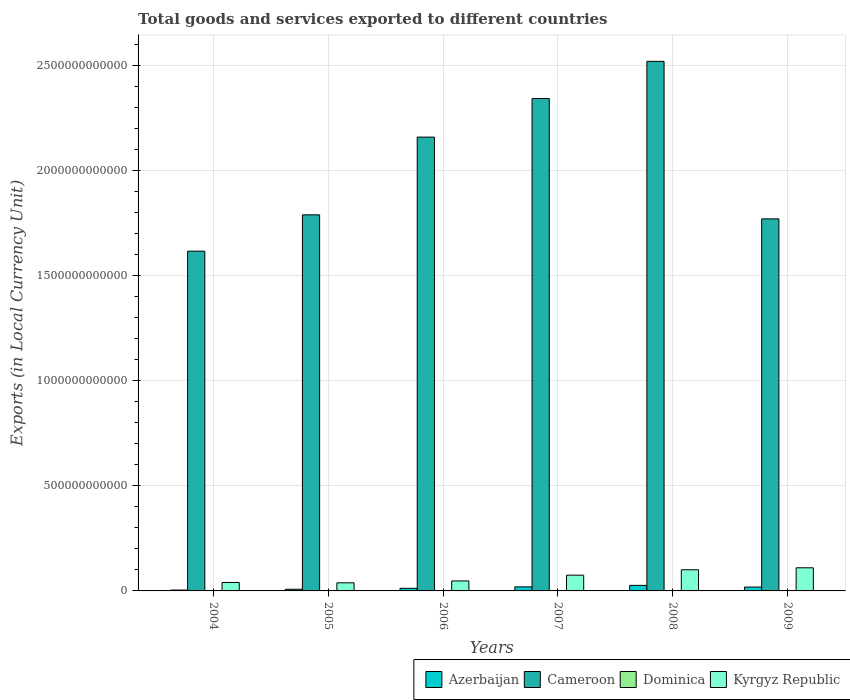How many different coloured bars are there?
Keep it short and to the point. 4. How many groups of bars are there?
Keep it short and to the point. 6. What is the Amount of goods and services exports in Azerbaijan in 2009?
Offer a very short reply. 1.84e+1. Across all years, what is the maximum Amount of goods and services exports in Kyrgyz Republic?
Give a very brief answer. 1.10e+11. Across all years, what is the minimum Amount of goods and services exports in Cameroon?
Offer a very short reply. 1.62e+12. What is the total Amount of goods and services exports in Azerbaijan in the graph?
Give a very brief answer. 8.86e+1. What is the difference between the Amount of goods and services exports in Dominica in 2007 and that in 2008?
Keep it short and to the point. -2.40e+07. What is the difference between the Amount of goods and services exports in Azerbaijan in 2007 and the Amount of goods and services exports in Dominica in 2006?
Make the answer very short. 1.89e+1. What is the average Amount of goods and services exports in Azerbaijan per year?
Ensure brevity in your answer.  1.48e+1. In the year 2004, what is the difference between the Amount of goods and services exports in Dominica and Amount of goods and services exports in Kyrgyz Republic?
Your answer should be compact. -3.98e+1. What is the ratio of the Amount of goods and services exports in Cameroon in 2005 to that in 2007?
Provide a short and direct response. 0.76. Is the Amount of goods and services exports in Cameroon in 2006 less than that in 2007?
Keep it short and to the point. Yes. What is the difference between the highest and the second highest Amount of goods and services exports in Azerbaijan?
Your answer should be very brief. 7.08e+09. What is the difference between the highest and the lowest Amount of goods and services exports in Dominica?
Ensure brevity in your answer.  7.40e+07. In how many years, is the Amount of goods and services exports in Azerbaijan greater than the average Amount of goods and services exports in Azerbaijan taken over all years?
Offer a very short reply. 3. What does the 3rd bar from the left in 2005 represents?
Keep it short and to the point. Dominica. What does the 3rd bar from the right in 2006 represents?
Provide a short and direct response. Cameroon. Are all the bars in the graph horizontal?
Offer a terse response. No. How many years are there in the graph?
Make the answer very short. 6. What is the difference between two consecutive major ticks on the Y-axis?
Give a very brief answer. 5.00e+11. Are the values on the major ticks of Y-axis written in scientific E-notation?
Offer a very short reply. No. Does the graph contain grids?
Provide a succinct answer. Yes. Where does the legend appear in the graph?
Offer a very short reply. Bottom right. How are the legend labels stacked?
Your response must be concise. Horizontal. What is the title of the graph?
Provide a succinct answer. Total goods and services exported to different countries. What is the label or title of the Y-axis?
Ensure brevity in your answer.  Exports (in Local Currency Unit). What is the Exports (in Local Currency Unit) in Azerbaijan in 2004?
Provide a short and direct response. 4.16e+09. What is the Exports (in Local Currency Unit) of Cameroon in 2004?
Make the answer very short. 1.62e+12. What is the Exports (in Local Currency Unit) in Dominica in 2004?
Your response must be concise. 3.52e+08. What is the Exports (in Local Currency Unit) in Kyrgyz Republic in 2004?
Provide a succinct answer. 4.02e+1. What is the Exports (in Local Currency Unit) in Azerbaijan in 2005?
Offer a very short reply. 7.88e+09. What is the Exports (in Local Currency Unit) of Cameroon in 2005?
Make the answer very short. 1.79e+12. What is the Exports (in Local Currency Unit) in Dominica in 2005?
Make the answer very short. 3.49e+08. What is the Exports (in Local Currency Unit) in Kyrgyz Republic in 2005?
Provide a succinct answer. 3.86e+1. What is the Exports (in Local Currency Unit) in Azerbaijan in 2006?
Your response must be concise. 1.25e+1. What is the Exports (in Local Currency Unit) of Cameroon in 2006?
Provide a short and direct response. 2.16e+12. What is the Exports (in Local Currency Unit) of Dominica in 2006?
Give a very brief answer. 3.90e+08. What is the Exports (in Local Currency Unit) of Kyrgyz Republic in 2006?
Give a very brief answer. 4.75e+1. What is the Exports (in Local Currency Unit) in Azerbaijan in 2007?
Your answer should be compact. 1.93e+1. What is the Exports (in Local Currency Unit) in Cameroon in 2007?
Provide a short and direct response. 2.34e+12. What is the Exports (in Local Currency Unit) in Dominica in 2007?
Give a very brief answer. 3.99e+08. What is the Exports (in Local Currency Unit) of Kyrgyz Republic in 2007?
Offer a terse response. 7.51e+1. What is the Exports (in Local Currency Unit) of Azerbaijan in 2008?
Provide a short and direct response. 2.64e+1. What is the Exports (in Local Currency Unit) in Cameroon in 2008?
Your answer should be very brief. 2.52e+12. What is the Exports (in Local Currency Unit) of Dominica in 2008?
Give a very brief answer. 4.23e+08. What is the Exports (in Local Currency Unit) in Kyrgyz Republic in 2008?
Give a very brief answer. 1.01e+11. What is the Exports (in Local Currency Unit) in Azerbaijan in 2009?
Your answer should be compact. 1.84e+1. What is the Exports (in Local Currency Unit) of Cameroon in 2009?
Your answer should be very brief. 1.77e+12. What is the Exports (in Local Currency Unit) in Dominica in 2009?
Provide a short and direct response. 3.99e+08. What is the Exports (in Local Currency Unit) of Kyrgyz Republic in 2009?
Give a very brief answer. 1.10e+11. Across all years, what is the maximum Exports (in Local Currency Unit) of Azerbaijan?
Offer a terse response. 2.64e+1. Across all years, what is the maximum Exports (in Local Currency Unit) of Cameroon?
Give a very brief answer. 2.52e+12. Across all years, what is the maximum Exports (in Local Currency Unit) of Dominica?
Offer a terse response. 4.23e+08. Across all years, what is the maximum Exports (in Local Currency Unit) of Kyrgyz Republic?
Keep it short and to the point. 1.10e+11. Across all years, what is the minimum Exports (in Local Currency Unit) in Azerbaijan?
Your answer should be compact. 4.16e+09. Across all years, what is the minimum Exports (in Local Currency Unit) of Cameroon?
Ensure brevity in your answer.  1.62e+12. Across all years, what is the minimum Exports (in Local Currency Unit) of Dominica?
Ensure brevity in your answer.  3.49e+08. Across all years, what is the minimum Exports (in Local Currency Unit) in Kyrgyz Republic?
Keep it short and to the point. 3.86e+1. What is the total Exports (in Local Currency Unit) of Azerbaijan in the graph?
Make the answer very short. 8.86e+1. What is the total Exports (in Local Currency Unit) of Cameroon in the graph?
Keep it short and to the point. 1.22e+13. What is the total Exports (in Local Currency Unit) of Dominica in the graph?
Provide a short and direct response. 2.31e+09. What is the total Exports (in Local Currency Unit) of Kyrgyz Republic in the graph?
Provide a short and direct response. 4.12e+11. What is the difference between the Exports (in Local Currency Unit) of Azerbaijan in 2004 and that in 2005?
Give a very brief answer. -3.72e+09. What is the difference between the Exports (in Local Currency Unit) in Cameroon in 2004 and that in 2005?
Provide a short and direct response. -1.73e+11. What is the difference between the Exports (in Local Currency Unit) of Dominica in 2004 and that in 2005?
Offer a terse response. 3.29e+06. What is the difference between the Exports (in Local Currency Unit) in Kyrgyz Republic in 2004 and that in 2005?
Make the answer very short. 1.50e+09. What is the difference between the Exports (in Local Currency Unit) of Azerbaijan in 2004 and that in 2006?
Offer a very short reply. -8.31e+09. What is the difference between the Exports (in Local Currency Unit) in Cameroon in 2004 and that in 2006?
Your answer should be very brief. -5.43e+11. What is the difference between the Exports (in Local Currency Unit) in Dominica in 2004 and that in 2006?
Keep it short and to the point. -3.77e+07. What is the difference between the Exports (in Local Currency Unit) in Kyrgyz Republic in 2004 and that in 2006?
Provide a succinct answer. -7.33e+09. What is the difference between the Exports (in Local Currency Unit) of Azerbaijan in 2004 and that in 2007?
Make the answer very short. -1.52e+1. What is the difference between the Exports (in Local Currency Unit) in Cameroon in 2004 and that in 2007?
Offer a terse response. -7.26e+11. What is the difference between the Exports (in Local Currency Unit) of Dominica in 2004 and that in 2007?
Provide a succinct answer. -4.67e+07. What is the difference between the Exports (in Local Currency Unit) in Kyrgyz Republic in 2004 and that in 2007?
Keep it short and to the point. -3.49e+1. What is the difference between the Exports (in Local Currency Unit) of Azerbaijan in 2004 and that in 2008?
Your answer should be very brief. -2.22e+1. What is the difference between the Exports (in Local Currency Unit) in Cameroon in 2004 and that in 2008?
Ensure brevity in your answer.  -9.03e+11. What is the difference between the Exports (in Local Currency Unit) of Dominica in 2004 and that in 2008?
Provide a succinct answer. -7.07e+07. What is the difference between the Exports (in Local Currency Unit) of Kyrgyz Republic in 2004 and that in 2008?
Make the answer very short. -6.05e+1. What is the difference between the Exports (in Local Currency Unit) of Azerbaijan in 2004 and that in 2009?
Your answer should be very brief. -1.42e+1. What is the difference between the Exports (in Local Currency Unit) in Cameroon in 2004 and that in 2009?
Ensure brevity in your answer.  -1.54e+11. What is the difference between the Exports (in Local Currency Unit) of Dominica in 2004 and that in 2009?
Your response must be concise. -4.67e+07. What is the difference between the Exports (in Local Currency Unit) in Kyrgyz Republic in 2004 and that in 2009?
Offer a terse response. -6.99e+1. What is the difference between the Exports (in Local Currency Unit) in Azerbaijan in 2005 and that in 2006?
Your answer should be compact. -4.59e+09. What is the difference between the Exports (in Local Currency Unit) in Cameroon in 2005 and that in 2006?
Provide a short and direct response. -3.70e+11. What is the difference between the Exports (in Local Currency Unit) in Dominica in 2005 and that in 2006?
Provide a short and direct response. -4.10e+07. What is the difference between the Exports (in Local Currency Unit) of Kyrgyz Republic in 2005 and that in 2006?
Offer a terse response. -8.83e+09. What is the difference between the Exports (in Local Currency Unit) of Azerbaijan in 2005 and that in 2007?
Your answer should be compact. -1.14e+1. What is the difference between the Exports (in Local Currency Unit) in Cameroon in 2005 and that in 2007?
Provide a short and direct response. -5.54e+11. What is the difference between the Exports (in Local Currency Unit) of Dominica in 2005 and that in 2007?
Provide a succinct answer. -5.00e+07. What is the difference between the Exports (in Local Currency Unit) of Kyrgyz Republic in 2005 and that in 2007?
Your answer should be compact. -3.64e+1. What is the difference between the Exports (in Local Currency Unit) of Azerbaijan in 2005 and that in 2008?
Offer a very short reply. -1.85e+1. What is the difference between the Exports (in Local Currency Unit) in Cameroon in 2005 and that in 2008?
Offer a terse response. -7.30e+11. What is the difference between the Exports (in Local Currency Unit) in Dominica in 2005 and that in 2008?
Offer a terse response. -7.40e+07. What is the difference between the Exports (in Local Currency Unit) in Kyrgyz Republic in 2005 and that in 2008?
Make the answer very short. -6.20e+1. What is the difference between the Exports (in Local Currency Unit) in Azerbaijan in 2005 and that in 2009?
Offer a very short reply. -1.05e+1. What is the difference between the Exports (in Local Currency Unit) of Cameroon in 2005 and that in 2009?
Your answer should be very brief. 1.92e+1. What is the difference between the Exports (in Local Currency Unit) of Dominica in 2005 and that in 2009?
Give a very brief answer. -5.00e+07. What is the difference between the Exports (in Local Currency Unit) in Kyrgyz Republic in 2005 and that in 2009?
Ensure brevity in your answer.  -7.14e+1. What is the difference between the Exports (in Local Currency Unit) in Azerbaijan in 2006 and that in 2007?
Ensure brevity in your answer.  -6.85e+09. What is the difference between the Exports (in Local Currency Unit) of Cameroon in 2006 and that in 2007?
Provide a short and direct response. -1.84e+11. What is the difference between the Exports (in Local Currency Unit) in Dominica in 2006 and that in 2007?
Your response must be concise. -9.00e+06. What is the difference between the Exports (in Local Currency Unit) of Kyrgyz Republic in 2006 and that in 2007?
Offer a very short reply. -2.76e+1. What is the difference between the Exports (in Local Currency Unit) in Azerbaijan in 2006 and that in 2008?
Offer a very short reply. -1.39e+1. What is the difference between the Exports (in Local Currency Unit) in Cameroon in 2006 and that in 2008?
Give a very brief answer. -3.61e+11. What is the difference between the Exports (in Local Currency Unit) in Dominica in 2006 and that in 2008?
Ensure brevity in your answer.  -3.30e+07. What is the difference between the Exports (in Local Currency Unit) in Kyrgyz Republic in 2006 and that in 2008?
Your response must be concise. -5.32e+1. What is the difference between the Exports (in Local Currency Unit) of Azerbaijan in 2006 and that in 2009?
Your answer should be compact. -5.92e+09. What is the difference between the Exports (in Local Currency Unit) of Cameroon in 2006 and that in 2009?
Keep it short and to the point. 3.89e+11. What is the difference between the Exports (in Local Currency Unit) in Dominica in 2006 and that in 2009?
Offer a terse response. -9.00e+06. What is the difference between the Exports (in Local Currency Unit) in Kyrgyz Republic in 2006 and that in 2009?
Provide a succinct answer. -6.26e+1. What is the difference between the Exports (in Local Currency Unit) in Azerbaijan in 2007 and that in 2008?
Offer a very short reply. -7.08e+09. What is the difference between the Exports (in Local Currency Unit) of Cameroon in 2007 and that in 2008?
Provide a short and direct response. -1.77e+11. What is the difference between the Exports (in Local Currency Unit) of Dominica in 2007 and that in 2008?
Your answer should be very brief. -2.40e+07. What is the difference between the Exports (in Local Currency Unit) of Kyrgyz Republic in 2007 and that in 2008?
Your response must be concise. -2.56e+1. What is the difference between the Exports (in Local Currency Unit) of Azerbaijan in 2007 and that in 2009?
Give a very brief answer. 9.39e+08. What is the difference between the Exports (in Local Currency Unit) in Cameroon in 2007 and that in 2009?
Keep it short and to the point. 5.73e+11. What is the difference between the Exports (in Local Currency Unit) in Kyrgyz Republic in 2007 and that in 2009?
Keep it short and to the point. -3.50e+1. What is the difference between the Exports (in Local Currency Unit) of Azerbaijan in 2008 and that in 2009?
Provide a short and direct response. 8.02e+09. What is the difference between the Exports (in Local Currency Unit) in Cameroon in 2008 and that in 2009?
Offer a terse response. 7.50e+11. What is the difference between the Exports (in Local Currency Unit) in Dominica in 2008 and that in 2009?
Offer a terse response. 2.40e+07. What is the difference between the Exports (in Local Currency Unit) of Kyrgyz Republic in 2008 and that in 2009?
Ensure brevity in your answer.  -9.40e+09. What is the difference between the Exports (in Local Currency Unit) in Azerbaijan in 2004 and the Exports (in Local Currency Unit) in Cameroon in 2005?
Keep it short and to the point. -1.79e+12. What is the difference between the Exports (in Local Currency Unit) in Azerbaijan in 2004 and the Exports (in Local Currency Unit) in Dominica in 2005?
Your response must be concise. 3.81e+09. What is the difference between the Exports (in Local Currency Unit) in Azerbaijan in 2004 and the Exports (in Local Currency Unit) in Kyrgyz Republic in 2005?
Offer a terse response. -3.45e+1. What is the difference between the Exports (in Local Currency Unit) in Cameroon in 2004 and the Exports (in Local Currency Unit) in Dominica in 2005?
Your response must be concise. 1.62e+12. What is the difference between the Exports (in Local Currency Unit) of Cameroon in 2004 and the Exports (in Local Currency Unit) of Kyrgyz Republic in 2005?
Ensure brevity in your answer.  1.58e+12. What is the difference between the Exports (in Local Currency Unit) in Dominica in 2004 and the Exports (in Local Currency Unit) in Kyrgyz Republic in 2005?
Your answer should be compact. -3.83e+1. What is the difference between the Exports (in Local Currency Unit) in Azerbaijan in 2004 and the Exports (in Local Currency Unit) in Cameroon in 2006?
Offer a terse response. -2.16e+12. What is the difference between the Exports (in Local Currency Unit) in Azerbaijan in 2004 and the Exports (in Local Currency Unit) in Dominica in 2006?
Keep it short and to the point. 3.77e+09. What is the difference between the Exports (in Local Currency Unit) in Azerbaijan in 2004 and the Exports (in Local Currency Unit) in Kyrgyz Republic in 2006?
Ensure brevity in your answer.  -4.33e+1. What is the difference between the Exports (in Local Currency Unit) of Cameroon in 2004 and the Exports (in Local Currency Unit) of Dominica in 2006?
Offer a terse response. 1.62e+12. What is the difference between the Exports (in Local Currency Unit) of Cameroon in 2004 and the Exports (in Local Currency Unit) of Kyrgyz Republic in 2006?
Offer a very short reply. 1.57e+12. What is the difference between the Exports (in Local Currency Unit) of Dominica in 2004 and the Exports (in Local Currency Unit) of Kyrgyz Republic in 2006?
Ensure brevity in your answer.  -4.71e+1. What is the difference between the Exports (in Local Currency Unit) of Azerbaijan in 2004 and the Exports (in Local Currency Unit) of Cameroon in 2007?
Make the answer very short. -2.34e+12. What is the difference between the Exports (in Local Currency Unit) of Azerbaijan in 2004 and the Exports (in Local Currency Unit) of Dominica in 2007?
Your answer should be compact. 3.76e+09. What is the difference between the Exports (in Local Currency Unit) of Azerbaijan in 2004 and the Exports (in Local Currency Unit) of Kyrgyz Republic in 2007?
Ensure brevity in your answer.  -7.09e+1. What is the difference between the Exports (in Local Currency Unit) in Cameroon in 2004 and the Exports (in Local Currency Unit) in Dominica in 2007?
Your response must be concise. 1.62e+12. What is the difference between the Exports (in Local Currency Unit) in Cameroon in 2004 and the Exports (in Local Currency Unit) in Kyrgyz Republic in 2007?
Keep it short and to the point. 1.54e+12. What is the difference between the Exports (in Local Currency Unit) in Dominica in 2004 and the Exports (in Local Currency Unit) in Kyrgyz Republic in 2007?
Offer a very short reply. -7.47e+1. What is the difference between the Exports (in Local Currency Unit) of Azerbaijan in 2004 and the Exports (in Local Currency Unit) of Cameroon in 2008?
Provide a succinct answer. -2.52e+12. What is the difference between the Exports (in Local Currency Unit) of Azerbaijan in 2004 and the Exports (in Local Currency Unit) of Dominica in 2008?
Offer a terse response. 3.74e+09. What is the difference between the Exports (in Local Currency Unit) in Azerbaijan in 2004 and the Exports (in Local Currency Unit) in Kyrgyz Republic in 2008?
Your response must be concise. -9.65e+1. What is the difference between the Exports (in Local Currency Unit) of Cameroon in 2004 and the Exports (in Local Currency Unit) of Dominica in 2008?
Make the answer very short. 1.62e+12. What is the difference between the Exports (in Local Currency Unit) in Cameroon in 2004 and the Exports (in Local Currency Unit) in Kyrgyz Republic in 2008?
Offer a very short reply. 1.52e+12. What is the difference between the Exports (in Local Currency Unit) of Dominica in 2004 and the Exports (in Local Currency Unit) of Kyrgyz Republic in 2008?
Offer a very short reply. -1.00e+11. What is the difference between the Exports (in Local Currency Unit) in Azerbaijan in 2004 and the Exports (in Local Currency Unit) in Cameroon in 2009?
Give a very brief answer. -1.77e+12. What is the difference between the Exports (in Local Currency Unit) in Azerbaijan in 2004 and the Exports (in Local Currency Unit) in Dominica in 2009?
Keep it short and to the point. 3.76e+09. What is the difference between the Exports (in Local Currency Unit) in Azerbaijan in 2004 and the Exports (in Local Currency Unit) in Kyrgyz Republic in 2009?
Provide a short and direct response. -1.06e+11. What is the difference between the Exports (in Local Currency Unit) of Cameroon in 2004 and the Exports (in Local Currency Unit) of Dominica in 2009?
Your response must be concise. 1.62e+12. What is the difference between the Exports (in Local Currency Unit) of Cameroon in 2004 and the Exports (in Local Currency Unit) of Kyrgyz Republic in 2009?
Your answer should be compact. 1.51e+12. What is the difference between the Exports (in Local Currency Unit) of Dominica in 2004 and the Exports (in Local Currency Unit) of Kyrgyz Republic in 2009?
Your response must be concise. -1.10e+11. What is the difference between the Exports (in Local Currency Unit) in Azerbaijan in 2005 and the Exports (in Local Currency Unit) in Cameroon in 2006?
Offer a very short reply. -2.15e+12. What is the difference between the Exports (in Local Currency Unit) of Azerbaijan in 2005 and the Exports (in Local Currency Unit) of Dominica in 2006?
Ensure brevity in your answer.  7.49e+09. What is the difference between the Exports (in Local Currency Unit) of Azerbaijan in 2005 and the Exports (in Local Currency Unit) of Kyrgyz Republic in 2006?
Your answer should be very brief. -3.96e+1. What is the difference between the Exports (in Local Currency Unit) of Cameroon in 2005 and the Exports (in Local Currency Unit) of Dominica in 2006?
Your answer should be compact. 1.79e+12. What is the difference between the Exports (in Local Currency Unit) in Cameroon in 2005 and the Exports (in Local Currency Unit) in Kyrgyz Republic in 2006?
Provide a succinct answer. 1.74e+12. What is the difference between the Exports (in Local Currency Unit) in Dominica in 2005 and the Exports (in Local Currency Unit) in Kyrgyz Republic in 2006?
Your answer should be very brief. -4.71e+1. What is the difference between the Exports (in Local Currency Unit) of Azerbaijan in 2005 and the Exports (in Local Currency Unit) of Cameroon in 2007?
Offer a very short reply. -2.34e+12. What is the difference between the Exports (in Local Currency Unit) in Azerbaijan in 2005 and the Exports (in Local Currency Unit) in Dominica in 2007?
Offer a terse response. 7.48e+09. What is the difference between the Exports (in Local Currency Unit) in Azerbaijan in 2005 and the Exports (in Local Currency Unit) in Kyrgyz Republic in 2007?
Your answer should be very brief. -6.72e+1. What is the difference between the Exports (in Local Currency Unit) of Cameroon in 2005 and the Exports (in Local Currency Unit) of Dominica in 2007?
Make the answer very short. 1.79e+12. What is the difference between the Exports (in Local Currency Unit) in Cameroon in 2005 and the Exports (in Local Currency Unit) in Kyrgyz Republic in 2007?
Offer a very short reply. 1.71e+12. What is the difference between the Exports (in Local Currency Unit) of Dominica in 2005 and the Exports (in Local Currency Unit) of Kyrgyz Republic in 2007?
Provide a succinct answer. -7.47e+1. What is the difference between the Exports (in Local Currency Unit) of Azerbaijan in 2005 and the Exports (in Local Currency Unit) of Cameroon in 2008?
Keep it short and to the point. -2.51e+12. What is the difference between the Exports (in Local Currency Unit) in Azerbaijan in 2005 and the Exports (in Local Currency Unit) in Dominica in 2008?
Make the answer very short. 7.46e+09. What is the difference between the Exports (in Local Currency Unit) in Azerbaijan in 2005 and the Exports (in Local Currency Unit) in Kyrgyz Republic in 2008?
Ensure brevity in your answer.  -9.28e+1. What is the difference between the Exports (in Local Currency Unit) of Cameroon in 2005 and the Exports (in Local Currency Unit) of Dominica in 2008?
Your response must be concise. 1.79e+12. What is the difference between the Exports (in Local Currency Unit) of Cameroon in 2005 and the Exports (in Local Currency Unit) of Kyrgyz Republic in 2008?
Provide a short and direct response. 1.69e+12. What is the difference between the Exports (in Local Currency Unit) in Dominica in 2005 and the Exports (in Local Currency Unit) in Kyrgyz Republic in 2008?
Provide a succinct answer. -1.00e+11. What is the difference between the Exports (in Local Currency Unit) in Azerbaijan in 2005 and the Exports (in Local Currency Unit) in Cameroon in 2009?
Keep it short and to the point. -1.76e+12. What is the difference between the Exports (in Local Currency Unit) in Azerbaijan in 2005 and the Exports (in Local Currency Unit) in Dominica in 2009?
Your response must be concise. 7.48e+09. What is the difference between the Exports (in Local Currency Unit) in Azerbaijan in 2005 and the Exports (in Local Currency Unit) in Kyrgyz Republic in 2009?
Your answer should be compact. -1.02e+11. What is the difference between the Exports (in Local Currency Unit) in Cameroon in 2005 and the Exports (in Local Currency Unit) in Dominica in 2009?
Make the answer very short. 1.79e+12. What is the difference between the Exports (in Local Currency Unit) of Cameroon in 2005 and the Exports (in Local Currency Unit) of Kyrgyz Republic in 2009?
Provide a succinct answer. 1.68e+12. What is the difference between the Exports (in Local Currency Unit) in Dominica in 2005 and the Exports (in Local Currency Unit) in Kyrgyz Republic in 2009?
Your response must be concise. -1.10e+11. What is the difference between the Exports (in Local Currency Unit) in Azerbaijan in 2006 and the Exports (in Local Currency Unit) in Cameroon in 2007?
Your response must be concise. -2.33e+12. What is the difference between the Exports (in Local Currency Unit) in Azerbaijan in 2006 and the Exports (in Local Currency Unit) in Dominica in 2007?
Offer a terse response. 1.21e+1. What is the difference between the Exports (in Local Currency Unit) of Azerbaijan in 2006 and the Exports (in Local Currency Unit) of Kyrgyz Republic in 2007?
Your answer should be very brief. -6.26e+1. What is the difference between the Exports (in Local Currency Unit) in Cameroon in 2006 and the Exports (in Local Currency Unit) in Dominica in 2007?
Your answer should be very brief. 2.16e+12. What is the difference between the Exports (in Local Currency Unit) of Cameroon in 2006 and the Exports (in Local Currency Unit) of Kyrgyz Republic in 2007?
Provide a succinct answer. 2.08e+12. What is the difference between the Exports (in Local Currency Unit) in Dominica in 2006 and the Exports (in Local Currency Unit) in Kyrgyz Republic in 2007?
Provide a short and direct response. -7.47e+1. What is the difference between the Exports (in Local Currency Unit) in Azerbaijan in 2006 and the Exports (in Local Currency Unit) in Cameroon in 2008?
Provide a short and direct response. -2.51e+12. What is the difference between the Exports (in Local Currency Unit) of Azerbaijan in 2006 and the Exports (in Local Currency Unit) of Dominica in 2008?
Your answer should be very brief. 1.20e+1. What is the difference between the Exports (in Local Currency Unit) of Azerbaijan in 2006 and the Exports (in Local Currency Unit) of Kyrgyz Republic in 2008?
Ensure brevity in your answer.  -8.82e+1. What is the difference between the Exports (in Local Currency Unit) of Cameroon in 2006 and the Exports (in Local Currency Unit) of Dominica in 2008?
Make the answer very short. 2.16e+12. What is the difference between the Exports (in Local Currency Unit) in Cameroon in 2006 and the Exports (in Local Currency Unit) in Kyrgyz Republic in 2008?
Your answer should be compact. 2.06e+12. What is the difference between the Exports (in Local Currency Unit) in Dominica in 2006 and the Exports (in Local Currency Unit) in Kyrgyz Republic in 2008?
Keep it short and to the point. -1.00e+11. What is the difference between the Exports (in Local Currency Unit) of Azerbaijan in 2006 and the Exports (in Local Currency Unit) of Cameroon in 2009?
Offer a terse response. -1.76e+12. What is the difference between the Exports (in Local Currency Unit) in Azerbaijan in 2006 and the Exports (in Local Currency Unit) in Dominica in 2009?
Your answer should be compact. 1.21e+1. What is the difference between the Exports (in Local Currency Unit) of Azerbaijan in 2006 and the Exports (in Local Currency Unit) of Kyrgyz Republic in 2009?
Your response must be concise. -9.76e+1. What is the difference between the Exports (in Local Currency Unit) of Cameroon in 2006 and the Exports (in Local Currency Unit) of Dominica in 2009?
Ensure brevity in your answer.  2.16e+12. What is the difference between the Exports (in Local Currency Unit) of Cameroon in 2006 and the Exports (in Local Currency Unit) of Kyrgyz Republic in 2009?
Provide a short and direct response. 2.05e+12. What is the difference between the Exports (in Local Currency Unit) of Dominica in 2006 and the Exports (in Local Currency Unit) of Kyrgyz Republic in 2009?
Offer a terse response. -1.10e+11. What is the difference between the Exports (in Local Currency Unit) of Azerbaijan in 2007 and the Exports (in Local Currency Unit) of Cameroon in 2008?
Your answer should be very brief. -2.50e+12. What is the difference between the Exports (in Local Currency Unit) in Azerbaijan in 2007 and the Exports (in Local Currency Unit) in Dominica in 2008?
Make the answer very short. 1.89e+1. What is the difference between the Exports (in Local Currency Unit) of Azerbaijan in 2007 and the Exports (in Local Currency Unit) of Kyrgyz Republic in 2008?
Provide a short and direct response. -8.13e+1. What is the difference between the Exports (in Local Currency Unit) of Cameroon in 2007 and the Exports (in Local Currency Unit) of Dominica in 2008?
Make the answer very short. 2.34e+12. What is the difference between the Exports (in Local Currency Unit) of Cameroon in 2007 and the Exports (in Local Currency Unit) of Kyrgyz Republic in 2008?
Your response must be concise. 2.24e+12. What is the difference between the Exports (in Local Currency Unit) of Dominica in 2007 and the Exports (in Local Currency Unit) of Kyrgyz Republic in 2008?
Give a very brief answer. -1.00e+11. What is the difference between the Exports (in Local Currency Unit) of Azerbaijan in 2007 and the Exports (in Local Currency Unit) of Cameroon in 2009?
Your answer should be compact. -1.75e+12. What is the difference between the Exports (in Local Currency Unit) in Azerbaijan in 2007 and the Exports (in Local Currency Unit) in Dominica in 2009?
Offer a terse response. 1.89e+1. What is the difference between the Exports (in Local Currency Unit) of Azerbaijan in 2007 and the Exports (in Local Currency Unit) of Kyrgyz Republic in 2009?
Make the answer very short. -9.07e+1. What is the difference between the Exports (in Local Currency Unit) of Cameroon in 2007 and the Exports (in Local Currency Unit) of Dominica in 2009?
Give a very brief answer. 2.34e+12. What is the difference between the Exports (in Local Currency Unit) in Cameroon in 2007 and the Exports (in Local Currency Unit) in Kyrgyz Republic in 2009?
Offer a very short reply. 2.23e+12. What is the difference between the Exports (in Local Currency Unit) of Dominica in 2007 and the Exports (in Local Currency Unit) of Kyrgyz Republic in 2009?
Your response must be concise. -1.10e+11. What is the difference between the Exports (in Local Currency Unit) of Azerbaijan in 2008 and the Exports (in Local Currency Unit) of Cameroon in 2009?
Provide a short and direct response. -1.74e+12. What is the difference between the Exports (in Local Currency Unit) of Azerbaijan in 2008 and the Exports (in Local Currency Unit) of Dominica in 2009?
Your answer should be very brief. 2.60e+1. What is the difference between the Exports (in Local Currency Unit) of Azerbaijan in 2008 and the Exports (in Local Currency Unit) of Kyrgyz Republic in 2009?
Ensure brevity in your answer.  -8.37e+1. What is the difference between the Exports (in Local Currency Unit) in Cameroon in 2008 and the Exports (in Local Currency Unit) in Dominica in 2009?
Give a very brief answer. 2.52e+12. What is the difference between the Exports (in Local Currency Unit) in Cameroon in 2008 and the Exports (in Local Currency Unit) in Kyrgyz Republic in 2009?
Your response must be concise. 2.41e+12. What is the difference between the Exports (in Local Currency Unit) of Dominica in 2008 and the Exports (in Local Currency Unit) of Kyrgyz Republic in 2009?
Your response must be concise. -1.10e+11. What is the average Exports (in Local Currency Unit) in Azerbaijan per year?
Offer a very short reply. 1.48e+1. What is the average Exports (in Local Currency Unit) of Cameroon per year?
Make the answer very short. 2.03e+12. What is the average Exports (in Local Currency Unit) in Dominica per year?
Your answer should be compact. 3.85e+08. What is the average Exports (in Local Currency Unit) in Kyrgyz Republic per year?
Provide a succinct answer. 6.87e+1. In the year 2004, what is the difference between the Exports (in Local Currency Unit) of Azerbaijan and Exports (in Local Currency Unit) of Cameroon?
Keep it short and to the point. -1.61e+12. In the year 2004, what is the difference between the Exports (in Local Currency Unit) of Azerbaijan and Exports (in Local Currency Unit) of Dominica?
Make the answer very short. 3.81e+09. In the year 2004, what is the difference between the Exports (in Local Currency Unit) of Azerbaijan and Exports (in Local Currency Unit) of Kyrgyz Republic?
Your answer should be very brief. -3.60e+1. In the year 2004, what is the difference between the Exports (in Local Currency Unit) in Cameroon and Exports (in Local Currency Unit) in Dominica?
Offer a terse response. 1.62e+12. In the year 2004, what is the difference between the Exports (in Local Currency Unit) in Cameroon and Exports (in Local Currency Unit) in Kyrgyz Republic?
Make the answer very short. 1.58e+12. In the year 2004, what is the difference between the Exports (in Local Currency Unit) of Dominica and Exports (in Local Currency Unit) of Kyrgyz Republic?
Offer a very short reply. -3.98e+1. In the year 2005, what is the difference between the Exports (in Local Currency Unit) in Azerbaijan and Exports (in Local Currency Unit) in Cameroon?
Provide a succinct answer. -1.78e+12. In the year 2005, what is the difference between the Exports (in Local Currency Unit) of Azerbaijan and Exports (in Local Currency Unit) of Dominica?
Your response must be concise. 7.53e+09. In the year 2005, what is the difference between the Exports (in Local Currency Unit) in Azerbaijan and Exports (in Local Currency Unit) in Kyrgyz Republic?
Your answer should be very brief. -3.08e+1. In the year 2005, what is the difference between the Exports (in Local Currency Unit) of Cameroon and Exports (in Local Currency Unit) of Dominica?
Provide a short and direct response. 1.79e+12. In the year 2005, what is the difference between the Exports (in Local Currency Unit) of Cameroon and Exports (in Local Currency Unit) of Kyrgyz Republic?
Offer a very short reply. 1.75e+12. In the year 2005, what is the difference between the Exports (in Local Currency Unit) of Dominica and Exports (in Local Currency Unit) of Kyrgyz Republic?
Ensure brevity in your answer.  -3.83e+1. In the year 2006, what is the difference between the Exports (in Local Currency Unit) in Azerbaijan and Exports (in Local Currency Unit) in Cameroon?
Provide a short and direct response. -2.15e+12. In the year 2006, what is the difference between the Exports (in Local Currency Unit) in Azerbaijan and Exports (in Local Currency Unit) in Dominica?
Offer a terse response. 1.21e+1. In the year 2006, what is the difference between the Exports (in Local Currency Unit) of Azerbaijan and Exports (in Local Currency Unit) of Kyrgyz Republic?
Your answer should be compact. -3.50e+1. In the year 2006, what is the difference between the Exports (in Local Currency Unit) in Cameroon and Exports (in Local Currency Unit) in Dominica?
Provide a succinct answer. 2.16e+12. In the year 2006, what is the difference between the Exports (in Local Currency Unit) of Cameroon and Exports (in Local Currency Unit) of Kyrgyz Republic?
Keep it short and to the point. 2.11e+12. In the year 2006, what is the difference between the Exports (in Local Currency Unit) in Dominica and Exports (in Local Currency Unit) in Kyrgyz Republic?
Your answer should be very brief. -4.71e+1. In the year 2007, what is the difference between the Exports (in Local Currency Unit) of Azerbaijan and Exports (in Local Currency Unit) of Cameroon?
Your response must be concise. -2.32e+12. In the year 2007, what is the difference between the Exports (in Local Currency Unit) in Azerbaijan and Exports (in Local Currency Unit) in Dominica?
Keep it short and to the point. 1.89e+1. In the year 2007, what is the difference between the Exports (in Local Currency Unit) in Azerbaijan and Exports (in Local Currency Unit) in Kyrgyz Republic?
Provide a short and direct response. -5.58e+1. In the year 2007, what is the difference between the Exports (in Local Currency Unit) in Cameroon and Exports (in Local Currency Unit) in Dominica?
Your answer should be compact. 2.34e+12. In the year 2007, what is the difference between the Exports (in Local Currency Unit) of Cameroon and Exports (in Local Currency Unit) of Kyrgyz Republic?
Provide a short and direct response. 2.27e+12. In the year 2007, what is the difference between the Exports (in Local Currency Unit) of Dominica and Exports (in Local Currency Unit) of Kyrgyz Republic?
Keep it short and to the point. -7.47e+1. In the year 2008, what is the difference between the Exports (in Local Currency Unit) in Azerbaijan and Exports (in Local Currency Unit) in Cameroon?
Ensure brevity in your answer.  -2.49e+12. In the year 2008, what is the difference between the Exports (in Local Currency Unit) in Azerbaijan and Exports (in Local Currency Unit) in Dominica?
Offer a very short reply. 2.60e+1. In the year 2008, what is the difference between the Exports (in Local Currency Unit) in Azerbaijan and Exports (in Local Currency Unit) in Kyrgyz Republic?
Ensure brevity in your answer.  -7.43e+1. In the year 2008, what is the difference between the Exports (in Local Currency Unit) in Cameroon and Exports (in Local Currency Unit) in Dominica?
Offer a terse response. 2.52e+12. In the year 2008, what is the difference between the Exports (in Local Currency Unit) in Cameroon and Exports (in Local Currency Unit) in Kyrgyz Republic?
Your answer should be compact. 2.42e+12. In the year 2008, what is the difference between the Exports (in Local Currency Unit) in Dominica and Exports (in Local Currency Unit) in Kyrgyz Republic?
Give a very brief answer. -1.00e+11. In the year 2009, what is the difference between the Exports (in Local Currency Unit) of Azerbaijan and Exports (in Local Currency Unit) of Cameroon?
Provide a succinct answer. -1.75e+12. In the year 2009, what is the difference between the Exports (in Local Currency Unit) of Azerbaijan and Exports (in Local Currency Unit) of Dominica?
Your answer should be very brief. 1.80e+1. In the year 2009, what is the difference between the Exports (in Local Currency Unit) in Azerbaijan and Exports (in Local Currency Unit) in Kyrgyz Republic?
Offer a terse response. -9.17e+1. In the year 2009, what is the difference between the Exports (in Local Currency Unit) of Cameroon and Exports (in Local Currency Unit) of Dominica?
Give a very brief answer. 1.77e+12. In the year 2009, what is the difference between the Exports (in Local Currency Unit) in Cameroon and Exports (in Local Currency Unit) in Kyrgyz Republic?
Your answer should be very brief. 1.66e+12. In the year 2009, what is the difference between the Exports (in Local Currency Unit) in Dominica and Exports (in Local Currency Unit) in Kyrgyz Republic?
Provide a succinct answer. -1.10e+11. What is the ratio of the Exports (in Local Currency Unit) in Azerbaijan in 2004 to that in 2005?
Provide a short and direct response. 0.53. What is the ratio of the Exports (in Local Currency Unit) of Cameroon in 2004 to that in 2005?
Your answer should be very brief. 0.9. What is the ratio of the Exports (in Local Currency Unit) of Dominica in 2004 to that in 2005?
Offer a terse response. 1.01. What is the ratio of the Exports (in Local Currency Unit) in Kyrgyz Republic in 2004 to that in 2005?
Your answer should be very brief. 1.04. What is the ratio of the Exports (in Local Currency Unit) in Azerbaijan in 2004 to that in 2006?
Provide a succinct answer. 0.33. What is the ratio of the Exports (in Local Currency Unit) in Cameroon in 2004 to that in 2006?
Keep it short and to the point. 0.75. What is the ratio of the Exports (in Local Currency Unit) in Dominica in 2004 to that in 2006?
Offer a terse response. 0.9. What is the ratio of the Exports (in Local Currency Unit) of Kyrgyz Republic in 2004 to that in 2006?
Keep it short and to the point. 0.85. What is the ratio of the Exports (in Local Currency Unit) of Azerbaijan in 2004 to that in 2007?
Provide a short and direct response. 0.22. What is the ratio of the Exports (in Local Currency Unit) in Cameroon in 2004 to that in 2007?
Your response must be concise. 0.69. What is the ratio of the Exports (in Local Currency Unit) in Dominica in 2004 to that in 2007?
Ensure brevity in your answer.  0.88. What is the ratio of the Exports (in Local Currency Unit) of Kyrgyz Republic in 2004 to that in 2007?
Ensure brevity in your answer.  0.53. What is the ratio of the Exports (in Local Currency Unit) in Azerbaijan in 2004 to that in 2008?
Ensure brevity in your answer.  0.16. What is the ratio of the Exports (in Local Currency Unit) in Cameroon in 2004 to that in 2008?
Your answer should be compact. 0.64. What is the ratio of the Exports (in Local Currency Unit) of Dominica in 2004 to that in 2008?
Give a very brief answer. 0.83. What is the ratio of the Exports (in Local Currency Unit) in Kyrgyz Republic in 2004 to that in 2008?
Ensure brevity in your answer.  0.4. What is the ratio of the Exports (in Local Currency Unit) of Azerbaijan in 2004 to that in 2009?
Offer a very short reply. 0.23. What is the ratio of the Exports (in Local Currency Unit) in Cameroon in 2004 to that in 2009?
Provide a short and direct response. 0.91. What is the ratio of the Exports (in Local Currency Unit) in Dominica in 2004 to that in 2009?
Give a very brief answer. 0.88. What is the ratio of the Exports (in Local Currency Unit) of Kyrgyz Republic in 2004 to that in 2009?
Your answer should be very brief. 0.36. What is the ratio of the Exports (in Local Currency Unit) in Azerbaijan in 2005 to that in 2006?
Offer a terse response. 0.63. What is the ratio of the Exports (in Local Currency Unit) in Cameroon in 2005 to that in 2006?
Make the answer very short. 0.83. What is the ratio of the Exports (in Local Currency Unit) in Dominica in 2005 to that in 2006?
Give a very brief answer. 0.89. What is the ratio of the Exports (in Local Currency Unit) of Kyrgyz Republic in 2005 to that in 2006?
Offer a terse response. 0.81. What is the ratio of the Exports (in Local Currency Unit) of Azerbaijan in 2005 to that in 2007?
Your answer should be compact. 0.41. What is the ratio of the Exports (in Local Currency Unit) in Cameroon in 2005 to that in 2007?
Provide a succinct answer. 0.76. What is the ratio of the Exports (in Local Currency Unit) in Dominica in 2005 to that in 2007?
Give a very brief answer. 0.87. What is the ratio of the Exports (in Local Currency Unit) in Kyrgyz Republic in 2005 to that in 2007?
Provide a short and direct response. 0.51. What is the ratio of the Exports (in Local Currency Unit) in Azerbaijan in 2005 to that in 2008?
Your response must be concise. 0.3. What is the ratio of the Exports (in Local Currency Unit) of Cameroon in 2005 to that in 2008?
Your answer should be compact. 0.71. What is the ratio of the Exports (in Local Currency Unit) of Dominica in 2005 to that in 2008?
Ensure brevity in your answer.  0.83. What is the ratio of the Exports (in Local Currency Unit) of Kyrgyz Republic in 2005 to that in 2008?
Your answer should be very brief. 0.38. What is the ratio of the Exports (in Local Currency Unit) of Azerbaijan in 2005 to that in 2009?
Make the answer very short. 0.43. What is the ratio of the Exports (in Local Currency Unit) in Cameroon in 2005 to that in 2009?
Your answer should be compact. 1.01. What is the ratio of the Exports (in Local Currency Unit) of Dominica in 2005 to that in 2009?
Offer a very short reply. 0.87. What is the ratio of the Exports (in Local Currency Unit) of Kyrgyz Republic in 2005 to that in 2009?
Provide a succinct answer. 0.35. What is the ratio of the Exports (in Local Currency Unit) of Azerbaijan in 2006 to that in 2007?
Provide a succinct answer. 0.65. What is the ratio of the Exports (in Local Currency Unit) of Cameroon in 2006 to that in 2007?
Your answer should be compact. 0.92. What is the ratio of the Exports (in Local Currency Unit) in Dominica in 2006 to that in 2007?
Your response must be concise. 0.98. What is the ratio of the Exports (in Local Currency Unit) of Kyrgyz Republic in 2006 to that in 2007?
Provide a short and direct response. 0.63. What is the ratio of the Exports (in Local Currency Unit) of Azerbaijan in 2006 to that in 2008?
Offer a very short reply. 0.47. What is the ratio of the Exports (in Local Currency Unit) in Cameroon in 2006 to that in 2008?
Ensure brevity in your answer.  0.86. What is the ratio of the Exports (in Local Currency Unit) of Dominica in 2006 to that in 2008?
Your answer should be very brief. 0.92. What is the ratio of the Exports (in Local Currency Unit) of Kyrgyz Republic in 2006 to that in 2008?
Make the answer very short. 0.47. What is the ratio of the Exports (in Local Currency Unit) of Azerbaijan in 2006 to that in 2009?
Ensure brevity in your answer.  0.68. What is the ratio of the Exports (in Local Currency Unit) in Cameroon in 2006 to that in 2009?
Give a very brief answer. 1.22. What is the ratio of the Exports (in Local Currency Unit) in Dominica in 2006 to that in 2009?
Provide a short and direct response. 0.98. What is the ratio of the Exports (in Local Currency Unit) of Kyrgyz Republic in 2006 to that in 2009?
Provide a short and direct response. 0.43. What is the ratio of the Exports (in Local Currency Unit) of Azerbaijan in 2007 to that in 2008?
Offer a very short reply. 0.73. What is the ratio of the Exports (in Local Currency Unit) in Cameroon in 2007 to that in 2008?
Offer a terse response. 0.93. What is the ratio of the Exports (in Local Currency Unit) of Dominica in 2007 to that in 2008?
Make the answer very short. 0.94. What is the ratio of the Exports (in Local Currency Unit) in Kyrgyz Republic in 2007 to that in 2008?
Offer a terse response. 0.75. What is the ratio of the Exports (in Local Currency Unit) in Azerbaijan in 2007 to that in 2009?
Give a very brief answer. 1.05. What is the ratio of the Exports (in Local Currency Unit) in Cameroon in 2007 to that in 2009?
Provide a short and direct response. 1.32. What is the ratio of the Exports (in Local Currency Unit) of Dominica in 2007 to that in 2009?
Offer a terse response. 1. What is the ratio of the Exports (in Local Currency Unit) in Kyrgyz Republic in 2007 to that in 2009?
Offer a terse response. 0.68. What is the ratio of the Exports (in Local Currency Unit) of Azerbaijan in 2008 to that in 2009?
Your answer should be compact. 1.44. What is the ratio of the Exports (in Local Currency Unit) in Cameroon in 2008 to that in 2009?
Give a very brief answer. 1.42. What is the ratio of the Exports (in Local Currency Unit) in Dominica in 2008 to that in 2009?
Offer a very short reply. 1.06. What is the ratio of the Exports (in Local Currency Unit) in Kyrgyz Republic in 2008 to that in 2009?
Provide a short and direct response. 0.91. What is the difference between the highest and the second highest Exports (in Local Currency Unit) of Azerbaijan?
Make the answer very short. 7.08e+09. What is the difference between the highest and the second highest Exports (in Local Currency Unit) of Cameroon?
Your answer should be very brief. 1.77e+11. What is the difference between the highest and the second highest Exports (in Local Currency Unit) of Dominica?
Offer a very short reply. 2.40e+07. What is the difference between the highest and the second highest Exports (in Local Currency Unit) of Kyrgyz Republic?
Offer a very short reply. 9.40e+09. What is the difference between the highest and the lowest Exports (in Local Currency Unit) of Azerbaijan?
Offer a terse response. 2.22e+1. What is the difference between the highest and the lowest Exports (in Local Currency Unit) of Cameroon?
Provide a succinct answer. 9.03e+11. What is the difference between the highest and the lowest Exports (in Local Currency Unit) in Dominica?
Keep it short and to the point. 7.40e+07. What is the difference between the highest and the lowest Exports (in Local Currency Unit) of Kyrgyz Republic?
Your answer should be very brief. 7.14e+1. 